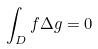Convert formula to latex. <formula><loc_0><loc_0><loc_500><loc_500>\int _ { D } f \Delta g = 0</formula> 